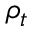<formula> <loc_0><loc_0><loc_500><loc_500>\rho _ { t }</formula> 